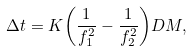Convert formula to latex. <formula><loc_0><loc_0><loc_500><loc_500>\Delta t = K { \left ( \frac { 1 } { f _ { 1 } ^ { 2 } } - \frac { 1 } { f _ { 2 } ^ { 2 } } \right ) } D M ,</formula> 